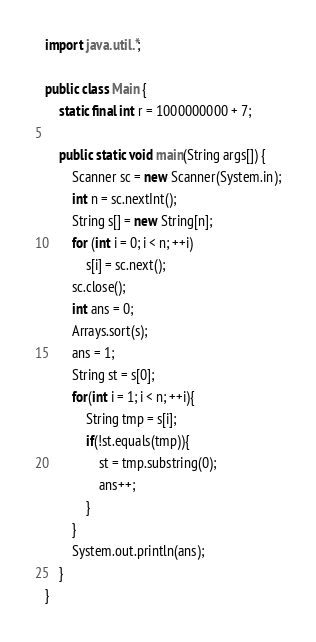Convert code to text. <code><loc_0><loc_0><loc_500><loc_500><_Java_>import java.util.*;

public class Main {
	static final int r = 1000000000 + 7;

	public static void main(String args[]) {
		Scanner sc = new Scanner(System.in);
		int n = sc.nextInt();
		String s[] = new String[n];
		for (int i = 0; i < n; ++i)
			s[i] = sc.next();
		sc.close();
		int ans = 0;
		Arrays.sort(s);
		ans = 1;
		String st = s[0];
		for(int i = 1; i < n; ++i){
			String tmp = s[i];
			if(!st.equals(tmp)){
				st = tmp.substring(0);
				ans++;
			}
		}
		System.out.println(ans);
	}
}
</code> 